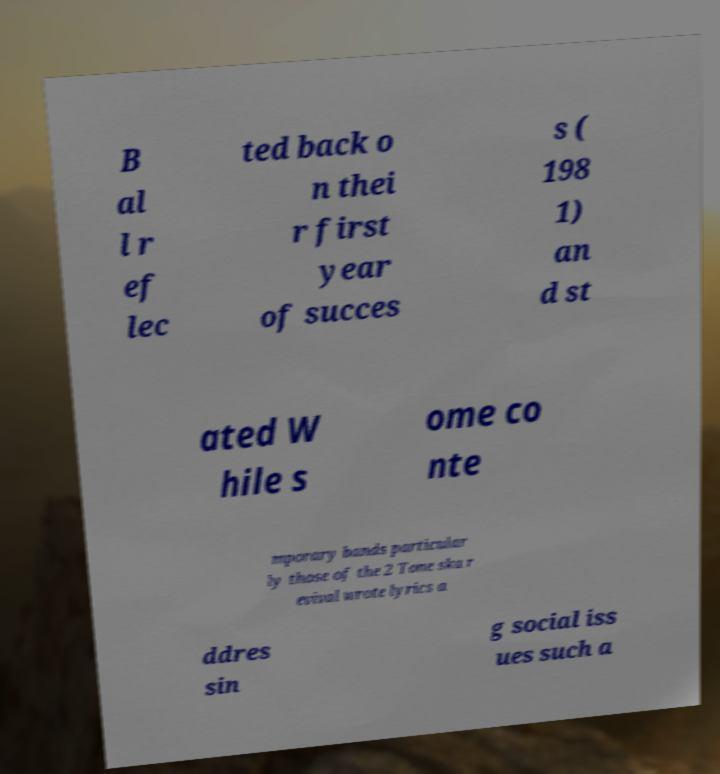For documentation purposes, I need the text within this image transcribed. Could you provide that? B al l r ef lec ted back o n thei r first year of succes s ( 198 1) an d st ated W hile s ome co nte mporary bands particular ly those of the 2 Tone ska r evival wrote lyrics a ddres sin g social iss ues such a 